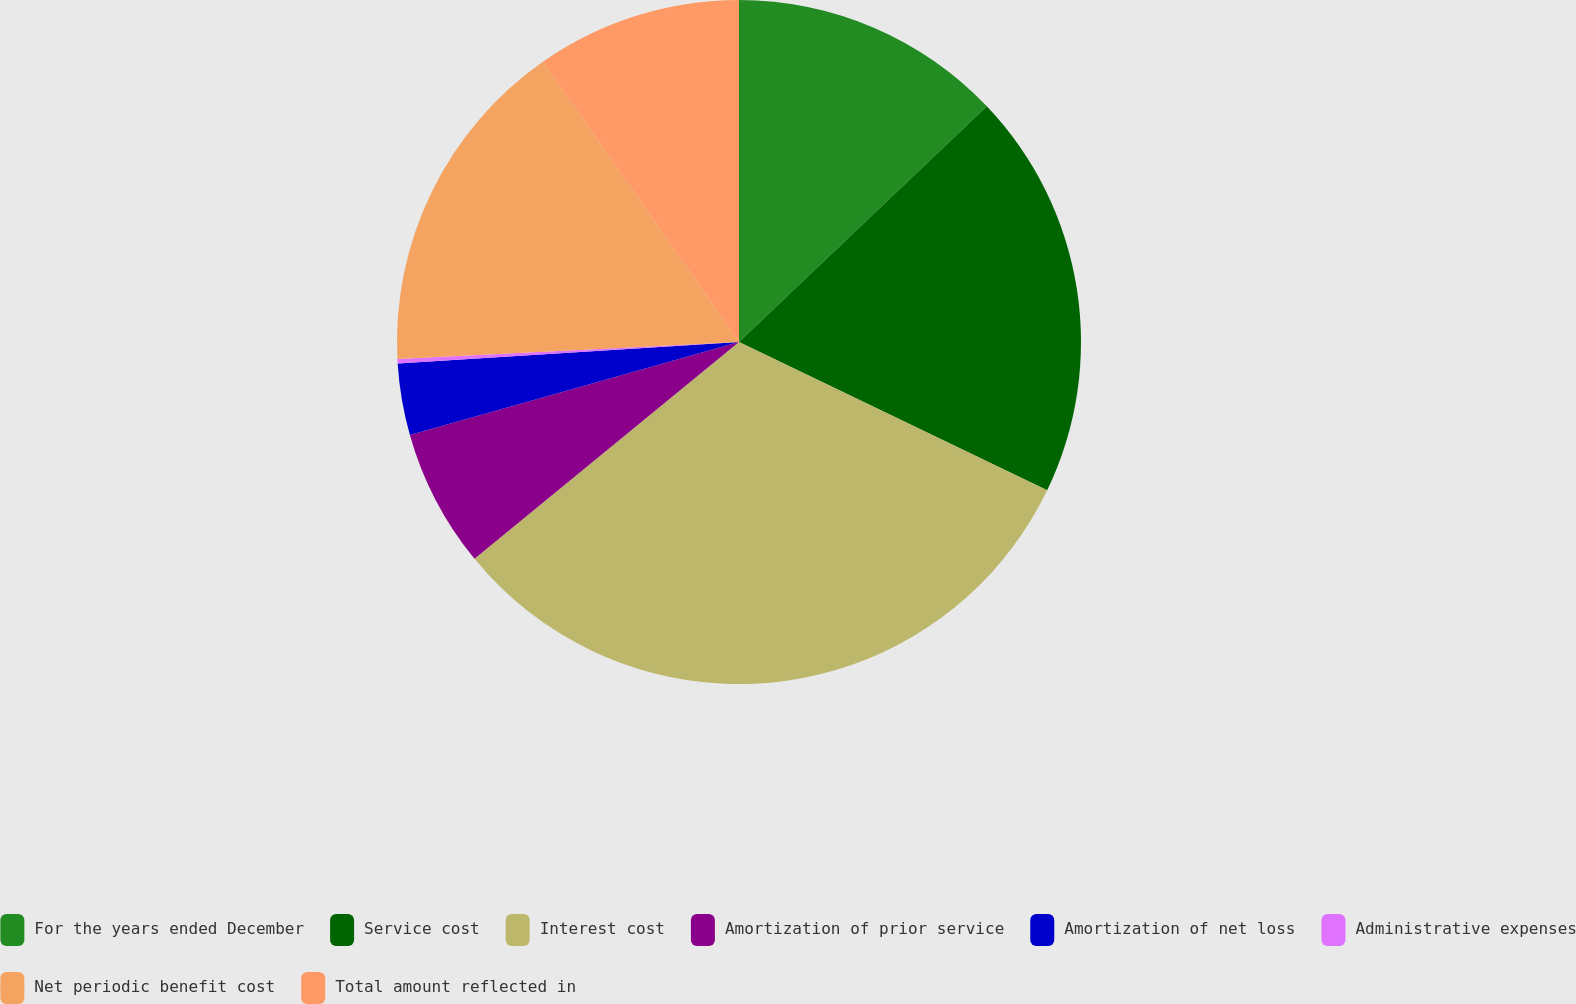<chart> <loc_0><loc_0><loc_500><loc_500><pie_chart><fcel>For the years ended December<fcel>Service cost<fcel>Interest cost<fcel>Amortization of prior service<fcel>Amortization of net loss<fcel>Administrative expenses<fcel>Net periodic benefit cost<fcel>Total amount reflected in<nl><fcel>12.9%<fcel>19.24%<fcel>31.93%<fcel>6.55%<fcel>3.38%<fcel>0.21%<fcel>16.07%<fcel>9.72%<nl></chart> 